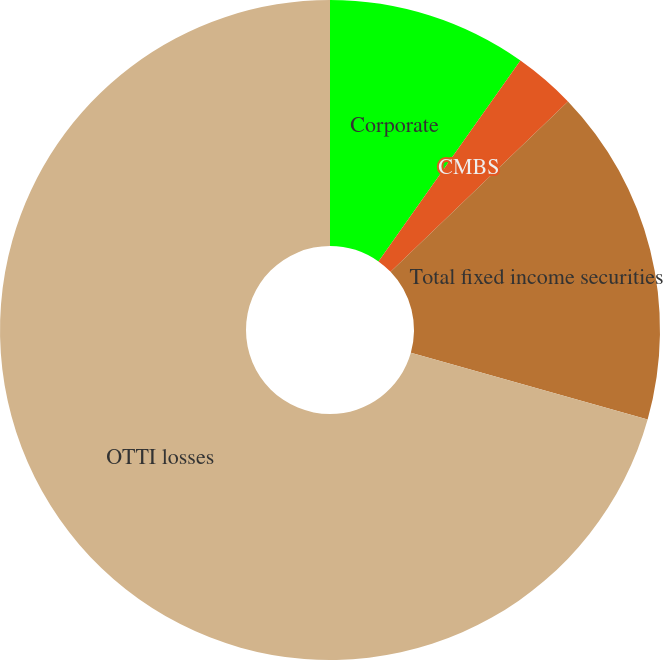Convert chart. <chart><loc_0><loc_0><loc_500><loc_500><pie_chart><fcel>Corporate<fcel>CMBS<fcel>Total fixed income securities<fcel>OTTI losses<nl><fcel>9.79%<fcel>3.03%<fcel>16.55%<fcel>70.63%<nl></chart> 